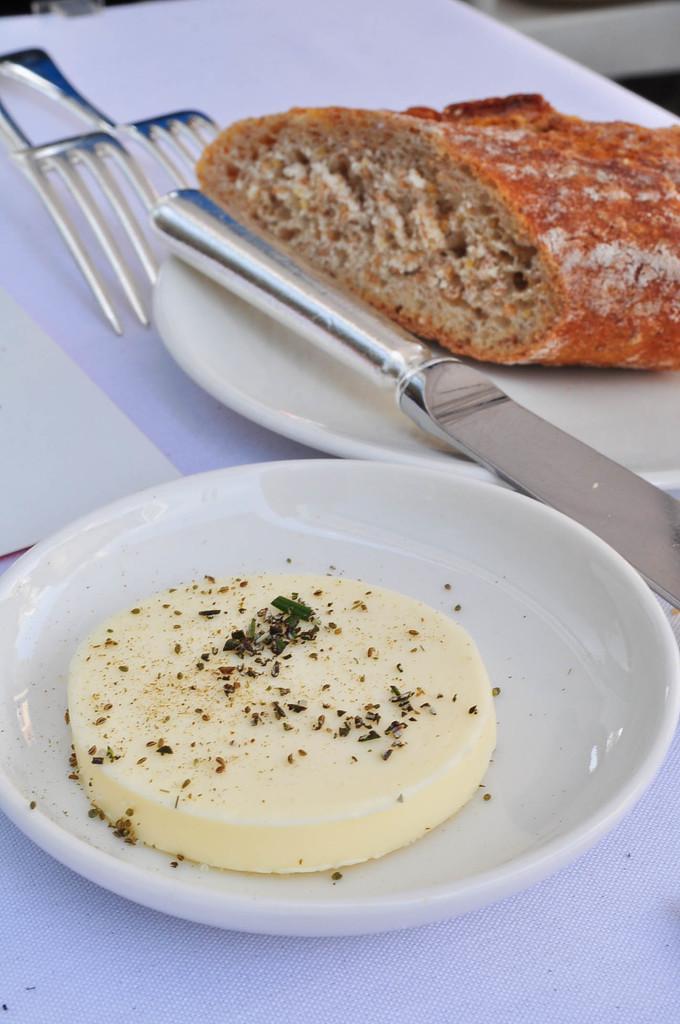Can you describe this image briefly? In the image I can see food items and a knife on a white color plate. I can also see forks and some other objects on a table. 